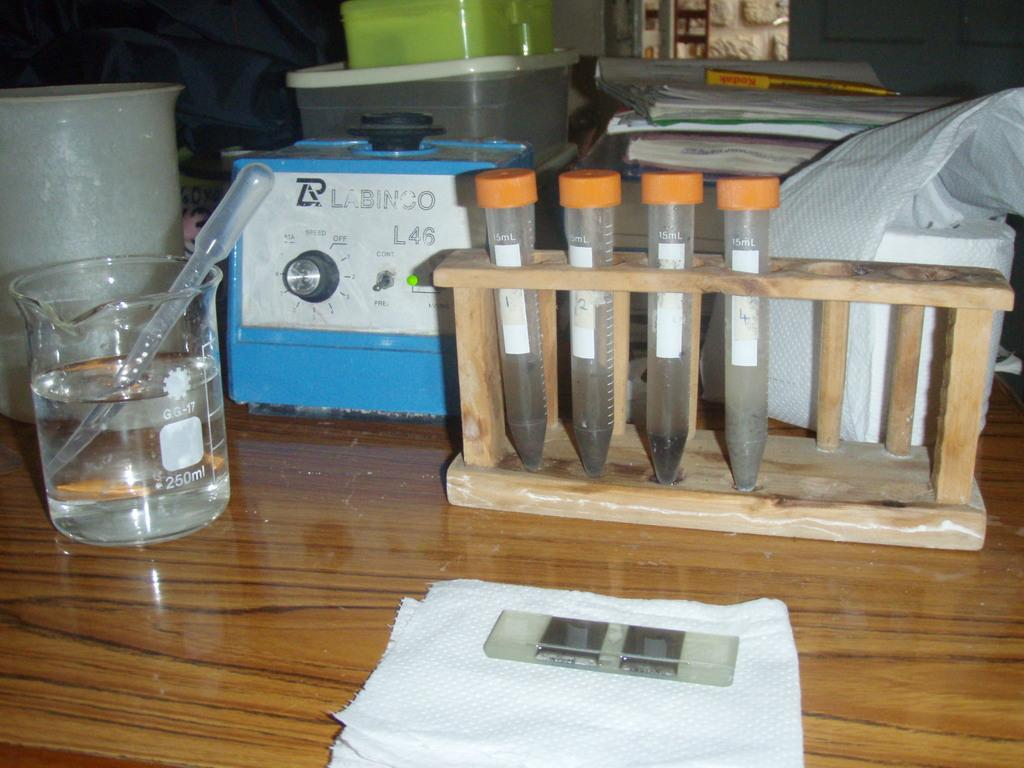<image>
Offer a succinct explanation of the picture presented. a counter on a science lab with a machine with Labinco on it 